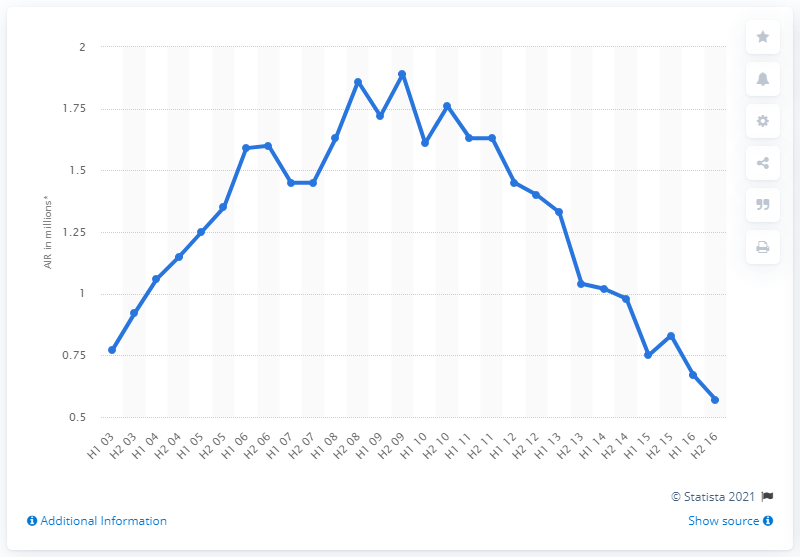Give some essential details in this illustration. In the second half of 2015, Closer magazine had an average of 0.83 readers per issue. 